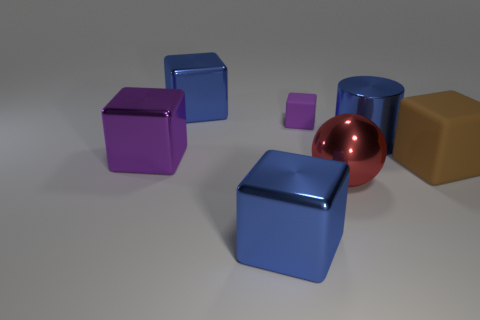Does the metal thing that is in front of the large red object have the same shape as the blue metal object that is behind the tiny purple rubber object?
Provide a short and direct response. Yes. What material is the small block?
Your response must be concise. Rubber. What shape is the big object that is the same color as the small cube?
Your response must be concise. Cube. What number of blue metallic cylinders have the same size as the red metallic object?
Make the answer very short. 1. What number of things are either big cubes that are left of the red ball or rubber cubes that are behind the big rubber thing?
Provide a succinct answer. 4. Are the purple object behind the large shiny cylinder and the blue thing to the right of the tiny rubber cube made of the same material?
Keep it short and to the point. No. The large blue object to the left of the blue shiny block in front of the large metal cylinder is what shape?
Ensure brevity in your answer.  Cube. Are there any other things of the same color as the big cylinder?
Provide a short and direct response. Yes. There is a blue block that is behind the blue object in front of the red metal ball; is there a blue metallic object on the right side of it?
Provide a succinct answer. Yes. There is a large shiny cylinder in front of the small matte object; is its color the same as the cube that is in front of the brown matte thing?
Make the answer very short. Yes. 